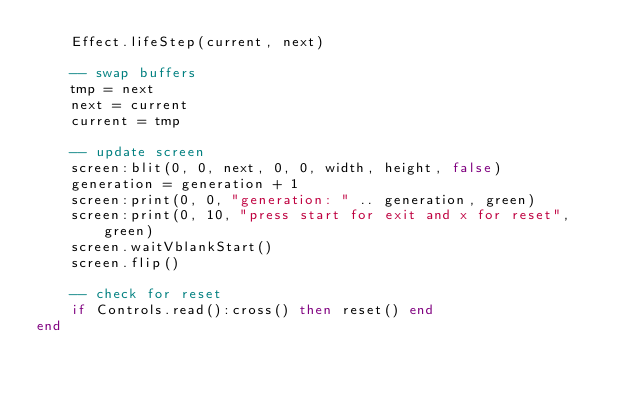Convert code to text. <code><loc_0><loc_0><loc_500><loc_500><_Lua_>	Effect.lifeStep(current, next)

	-- swap buffers
	tmp = next
	next = current
	current = tmp

	-- update screen
	screen:blit(0, 0, next, 0, 0, width, height, false)
	generation = generation + 1
	screen:print(0, 0, "generation: " .. generation, green)
	screen:print(0, 10, "press start for exit and x for reset", green)
	screen.waitVblankStart()
	screen.flip()
	
	-- check for reset
	if Controls.read():cross() then reset() end
end
</code> 